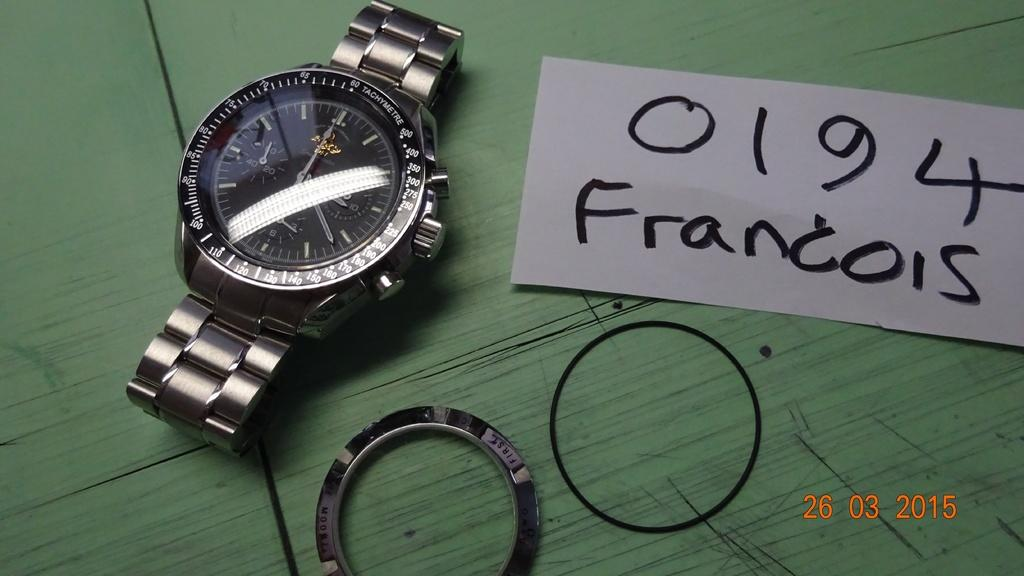Provide a one-sentence caption for the provided image. A watch is on display, with a notecard reading "0194 Francois" next to it. 